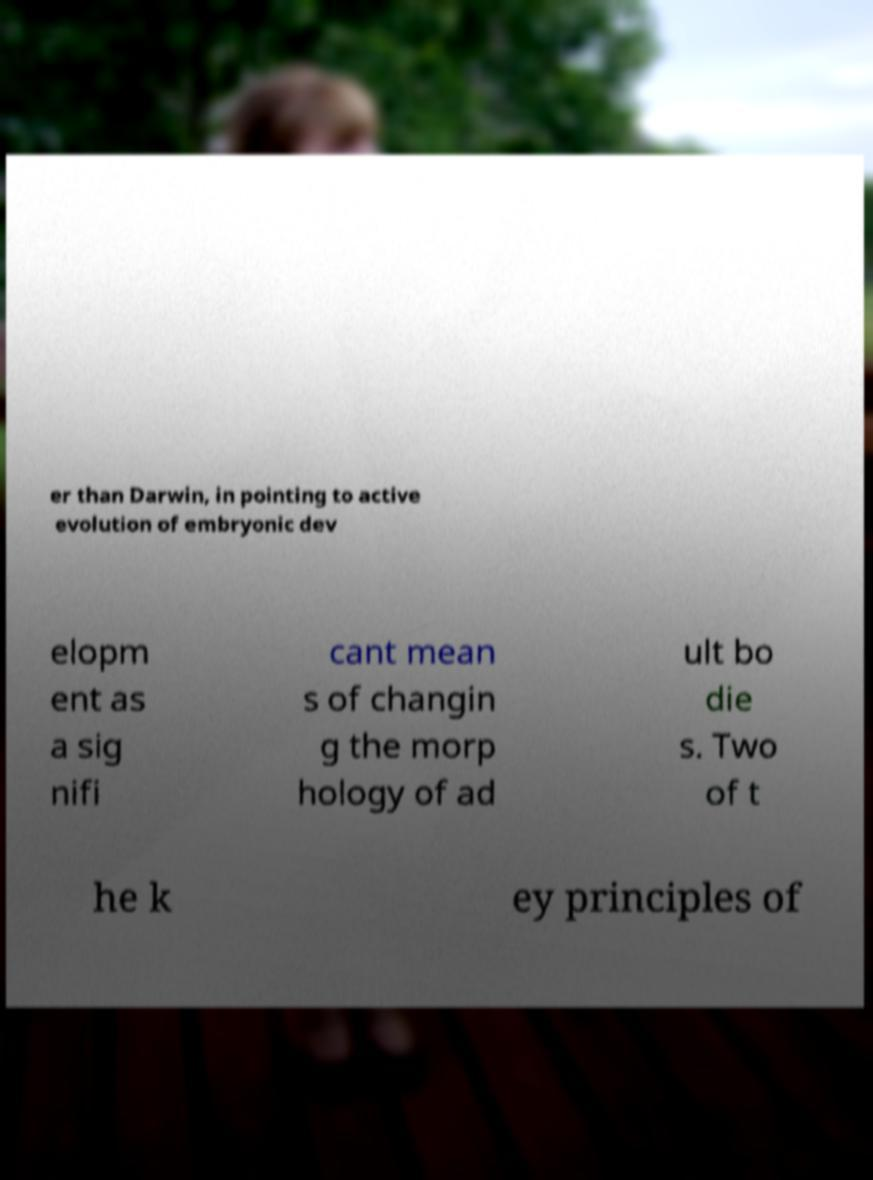Could you extract and type out the text from this image? er than Darwin, in pointing to active evolution of embryonic dev elopm ent as a sig nifi cant mean s of changin g the morp hology of ad ult bo die s. Two of t he k ey principles of 